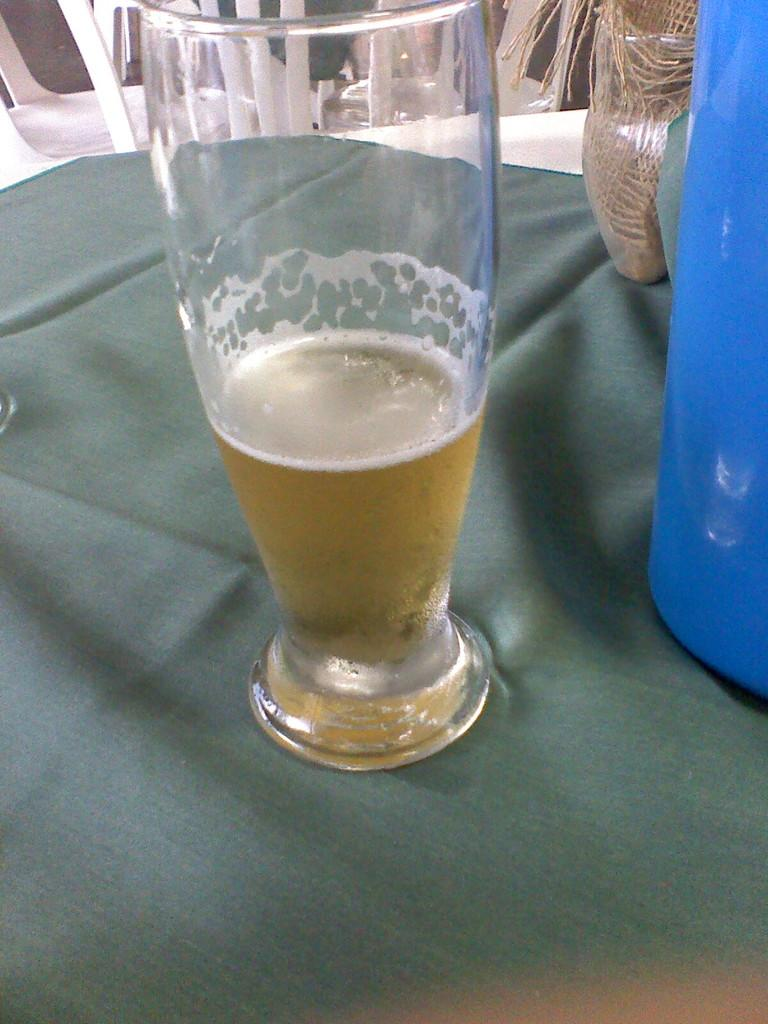What is in the glass that is visible in the image? There is a drink in the glass in the image. What else can be seen in the image besides the glass? There is a cloth and other objects on the table in the image. What is visible in the background of the image? There are chairs in the background of the image. Is there a window in the image that can be locked? There is no window present in the image, so it cannot be locked. 